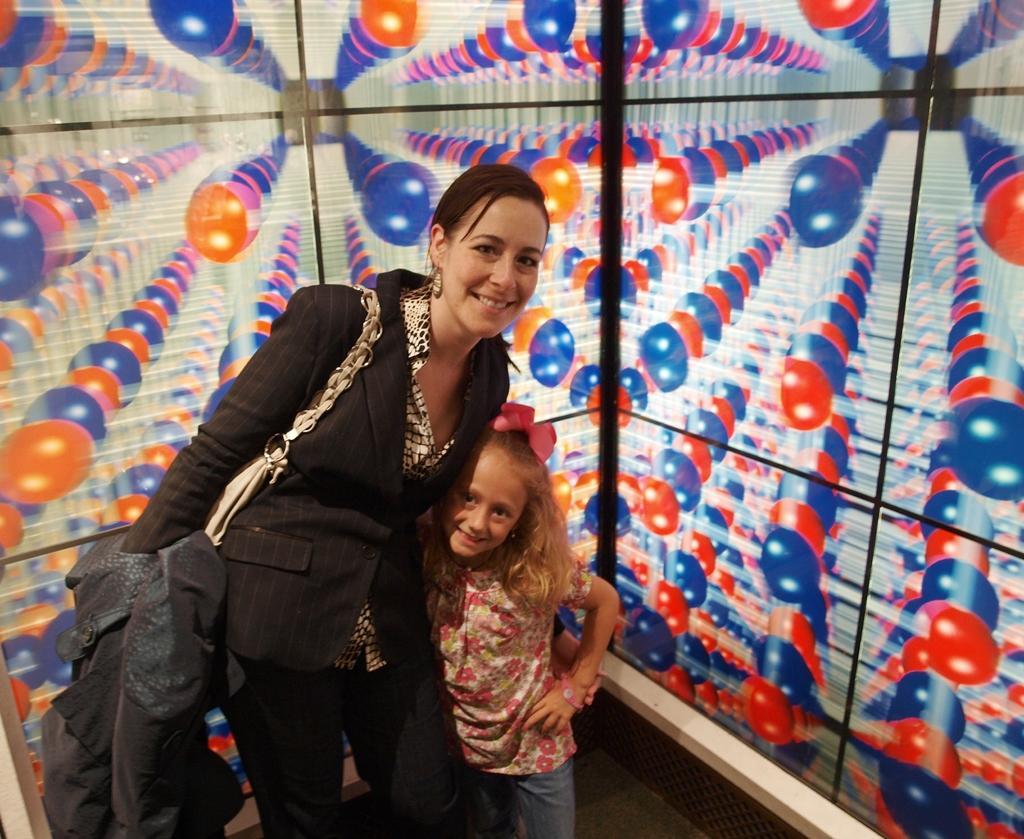In one or two sentences, can you explain what this image depicts? This woman and girl are standing and smiling. Background there is a colorful wall. 